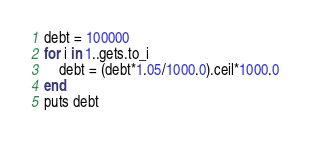Convert code to text. <code><loc_0><loc_0><loc_500><loc_500><_Ruby_>debt = 100000
for i in 1..gets.to_i
	debt = (debt*1.05/1000.0).ceil*1000.0
end
puts debt</code> 